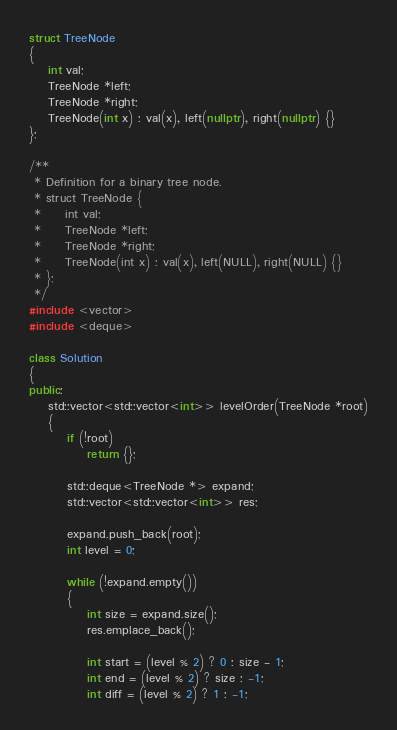<code> <loc_0><loc_0><loc_500><loc_500><_C++_>struct TreeNode
{
    int val;
    TreeNode *left;
    TreeNode *right;
    TreeNode(int x) : val(x), left(nullptr), right(nullptr) {}
};

/**
 * Definition for a binary tree node.
 * struct TreeNode {
 *     int val;
 *     TreeNode *left;
 *     TreeNode *right;
 *     TreeNode(int x) : val(x), left(NULL), right(NULL) {}
 * };
 */
#include <vector>
#include <deque>

class Solution
{
public:
    std::vector<std::vector<int>> levelOrder(TreeNode *root)
    {
        if (!root)
            return {};

        std::deque<TreeNode *> expand;
        std::vector<std::vector<int>> res;

        expand.push_back(root);
        int level = 0;

        while (!expand.empty())
        {
            int size = expand.size();
            res.emplace_back();

            int start = (level % 2) ? 0 : size - 1;
            int end = (level % 2) ? size : -1;
            int diff = (level % 2) ? 1 : -1; </code> 